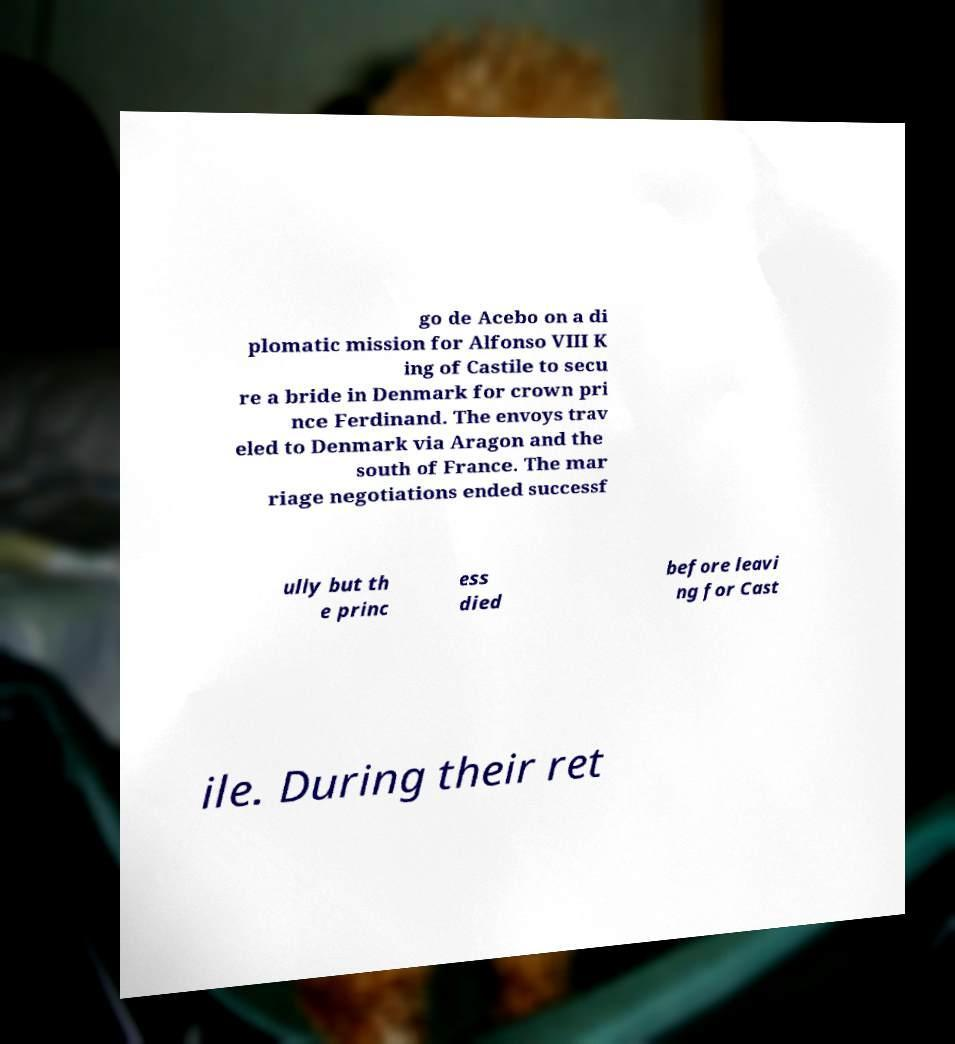Could you assist in decoding the text presented in this image and type it out clearly? go de Acebo on a di plomatic mission for Alfonso VIII K ing of Castile to secu re a bride in Denmark for crown pri nce Ferdinand. The envoys trav eled to Denmark via Aragon and the south of France. The mar riage negotiations ended successf ully but th e princ ess died before leavi ng for Cast ile. During their ret 